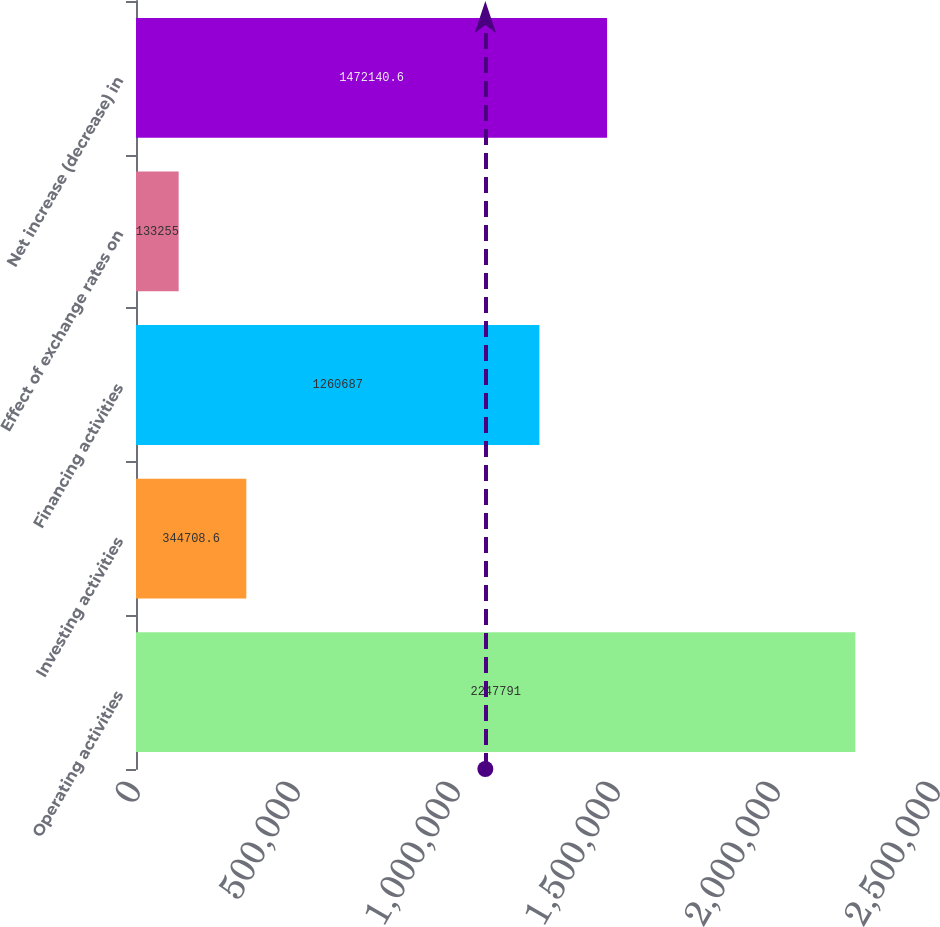Convert chart to OTSL. <chart><loc_0><loc_0><loc_500><loc_500><bar_chart><fcel>Operating activities<fcel>Investing activities<fcel>Financing activities<fcel>Effect of exchange rates on<fcel>Net increase (decrease) in<nl><fcel>2.24779e+06<fcel>344709<fcel>1.26069e+06<fcel>133255<fcel>1.47214e+06<nl></chart> 